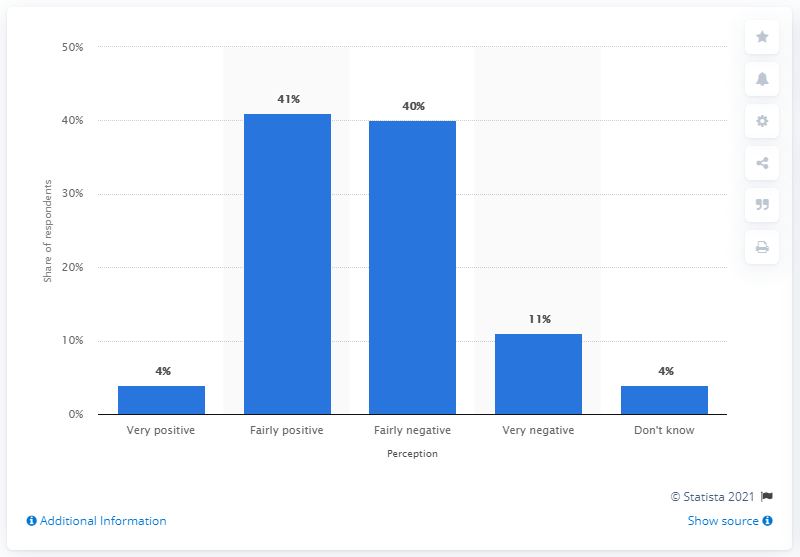Indicate a few pertinent items in this graphic. The sum of very negative and fairly negative perception is 51. 41% of respondents have a fairly positive perception towards the brand. 